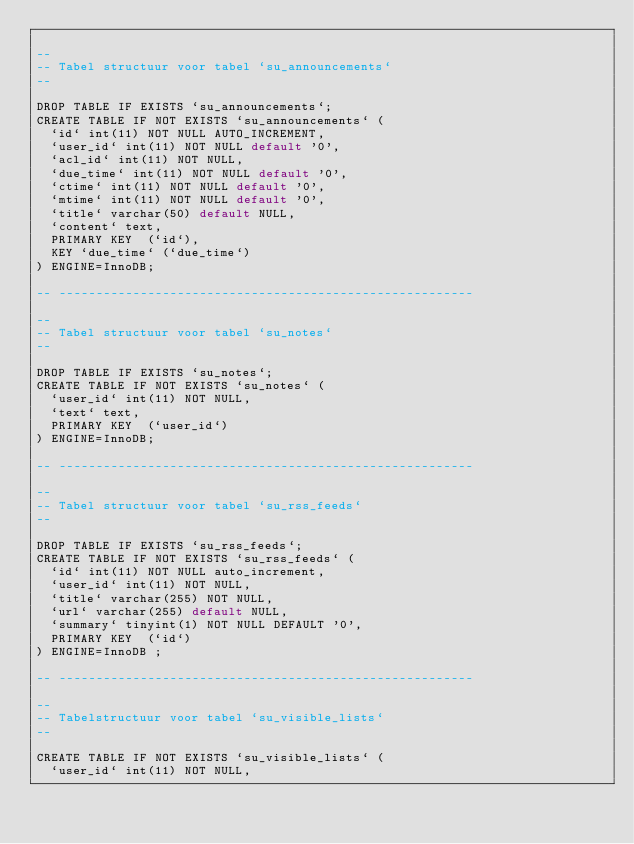Convert code to text. <code><loc_0><loc_0><loc_500><loc_500><_SQL_>
--
-- Tabel structuur voor tabel `su_announcements`
--

DROP TABLE IF EXISTS `su_announcements`;
CREATE TABLE IF NOT EXISTS `su_announcements` (
  `id` int(11) NOT NULL AUTO_INCREMENT,
  `user_id` int(11) NOT NULL default '0',
  `acl_id` int(11) NOT NULL,
  `due_time` int(11) NOT NULL default '0',
  `ctime` int(11) NOT NULL default '0',
  `mtime` int(11) NOT NULL default '0',
  `title` varchar(50) default NULL,
  `content` text,
  PRIMARY KEY  (`id`),
  KEY `due_time` (`due_time`)
) ENGINE=InnoDB;

-- --------------------------------------------------------

--
-- Tabel structuur voor tabel `su_notes`
--

DROP TABLE IF EXISTS `su_notes`;
CREATE TABLE IF NOT EXISTS `su_notes` (
  `user_id` int(11) NOT NULL,
  `text` text,
  PRIMARY KEY  (`user_id`)
) ENGINE=InnoDB;

-- --------------------------------------------------------

--
-- Tabel structuur voor tabel `su_rss_feeds`
--

DROP TABLE IF EXISTS `su_rss_feeds`;
CREATE TABLE IF NOT EXISTS `su_rss_feeds` (
  `id` int(11) NOT NULL auto_increment,
  `user_id` int(11) NOT NULL,
  `title` varchar(255) NOT NULL,
  `url` varchar(255) default NULL,
  `summary` tinyint(1) NOT NULL DEFAULT '0',
  PRIMARY KEY  (`id`)
) ENGINE=InnoDB ;

-- --------------------------------------------------------

--
-- Tabelstructuur voor tabel `su_visible_lists`
--

CREATE TABLE IF NOT EXISTS `su_visible_lists` (
  `user_id` int(11) NOT NULL,</code> 